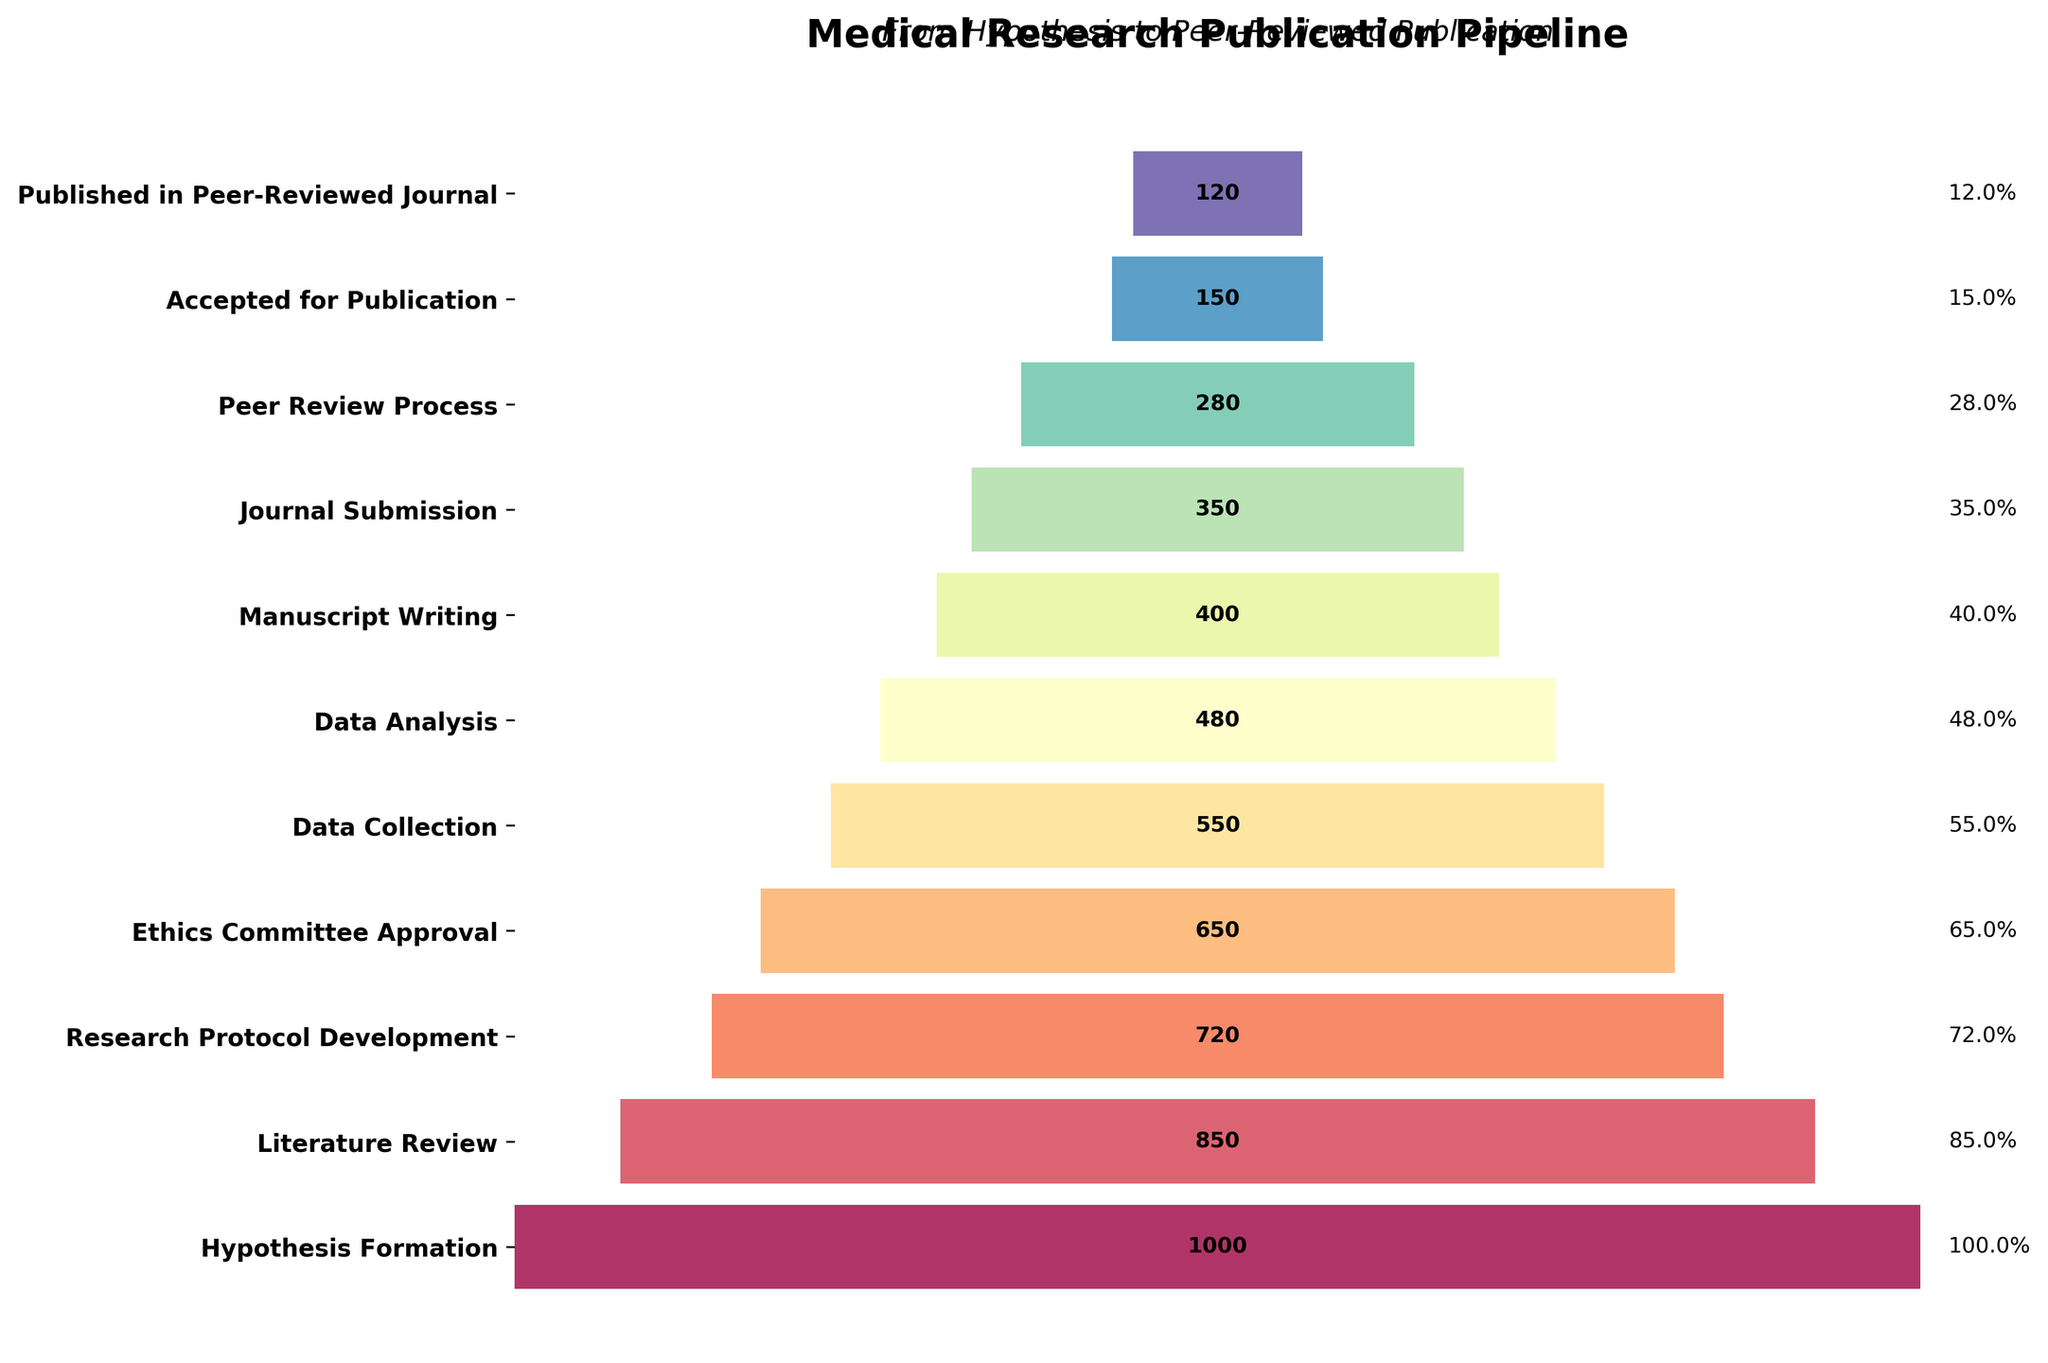What is the title of the plot? The title of the plot is written at the top and reads "Medical Research Publication Pipeline".
Answer: Medical Research Publication Pipeline What is the second stage in the funnel chart? The stages are listed vertically from top to bottom; the second stage is "Literature Review".
Answer: Literature Review How many projects reach the "Data Collection" stage? By looking to the left side, the "Data Collection" stage shows the number 550.
Answer: 550 Calculate the percentage of projects that get published in a peer-reviewed journal compared to those at the hypothesis formation stage. The figure shows that there are 120 projects published out of 1000 at the hypothesis formation stage. The calculation is (120/1000)*100 = 12%.
Answer: 12% Which stage has the largest drop in the number of projects compared to its previous stage? The figure shows the vertical bars; by comparing the differences in project numbers stage-by-stage, the largest drop is between the "Peer Review Process" (280) and "Accepted for Publication" (150). The difference is 280 - 150 = 130.
Answer: Peer Review Process to Accepted for Publication What is the numerical difference in projects between "Research Protocol Development" and "Journal Submission"? The figure lists 720 projects for "Research Protocol Development" and 350 projects for "Journal Submission". The difference is 720 - 350 = 370.
Answer: 370 What is the last stage in the funnel process? The lowest or final stage listed on the figure is "Published in Peer-Reviewed Journal".
Answer: Published in Peer-Reviewed Journal How many projects are rejected after the peer review process? The number of projects in the "Peer Review Process" is 280, and those accepted are 150. The difference is 280 - 150 = 130.
Answer: 130 Which stage occurs immediately before "Data Analysis"? According to the figure's order, "Data Collection" comes immediately before "Data Analysis".
Answer: Data Collection Considering stages from "Ethics Committee Approval" to "Journal Submission", what is the average number of projects remaining? The number of projects at each stage is 650 (Ethics Committee Approval), 550 (Data Collection), 480 (Data Analysis), 400 (Manuscript Writing), and 350 (Journal Submission). The sum is 650 + 550 + 480 + 400 + 350 = 2430. The average is 2430/5 = 486.
Answer: 486 